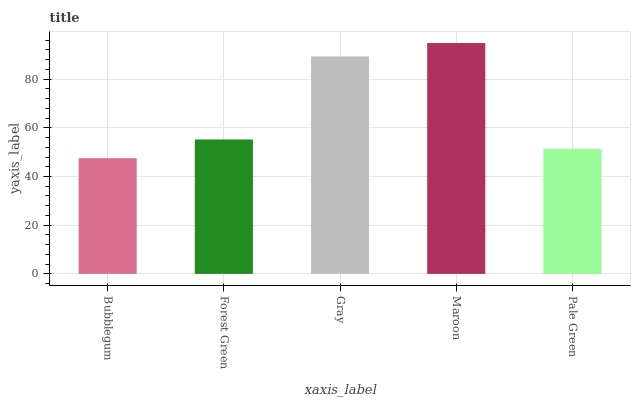Is Bubblegum the minimum?
Answer yes or no. Yes. Is Maroon the maximum?
Answer yes or no. Yes. Is Forest Green the minimum?
Answer yes or no. No. Is Forest Green the maximum?
Answer yes or no. No. Is Forest Green greater than Bubblegum?
Answer yes or no. Yes. Is Bubblegum less than Forest Green?
Answer yes or no. Yes. Is Bubblegum greater than Forest Green?
Answer yes or no. No. Is Forest Green less than Bubblegum?
Answer yes or no. No. Is Forest Green the high median?
Answer yes or no. Yes. Is Forest Green the low median?
Answer yes or no. Yes. Is Gray the high median?
Answer yes or no. No. Is Gray the low median?
Answer yes or no. No. 